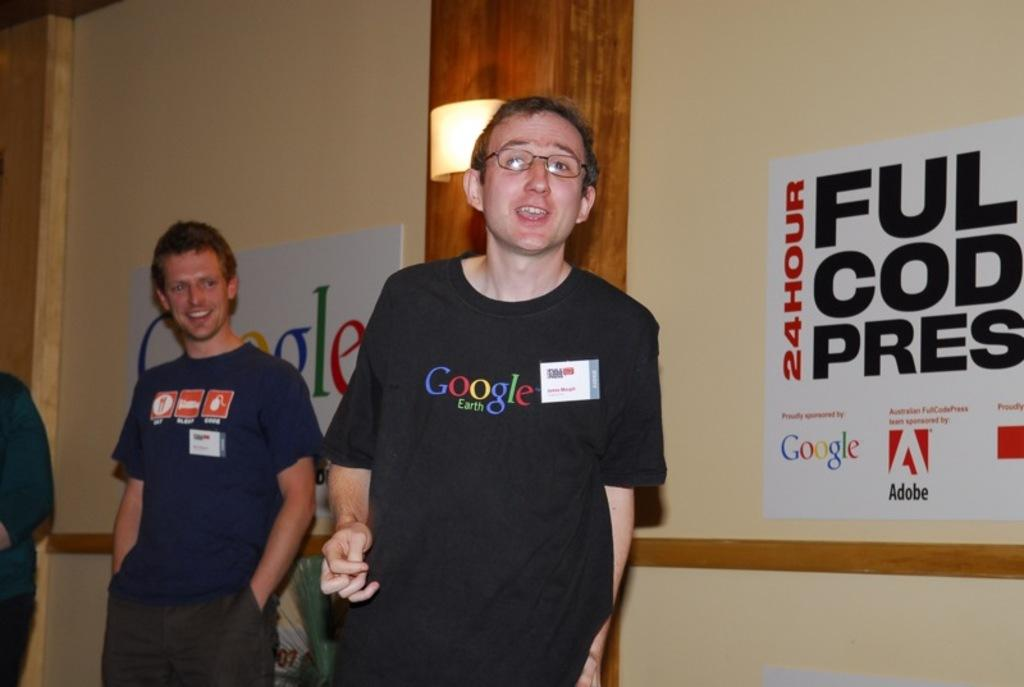How many people are present in the image? There are three persons in the image. What can be seen in the background of the image? There is a wall with posters and a pillar with light in the background of the image. What type of berry is hanging from the wall in the image? There are no berries present in the image; the background features a wall with posters and a pillar with light. 